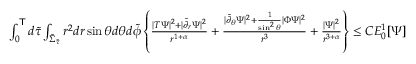<formula> <loc_0><loc_0><loc_500><loc_500>\begin{array} { r } { \int _ { 0 } ^ { T } d \widetilde { \tau } \int _ { \widetilde { \Sigma } _ { \widetilde { \tau } } } r ^ { 2 } d r \sin \theta d \theta d \widetilde { \phi } \left \{ \frac { | T \Psi | ^ { 2 } + | \widetilde { \partial } _ { r } \Psi | ^ { 2 } } { r ^ { 1 + \alpha } } + \frac { | \widetilde { \partial } _ { \theta } \Psi | ^ { 2 } + \frac { 1 } { \sin ^ { 2 } \theta } | \Phi \Psi | ^ { 2 } } { r ^ { 3 } } + \frac { | \Psi | ^ { 2 } } { r ^ { 3 + \alpha } } \right \} \leq C E _ { 0 } ^ { 1 } [ \Psi ] \, } \end{array}</formula> 